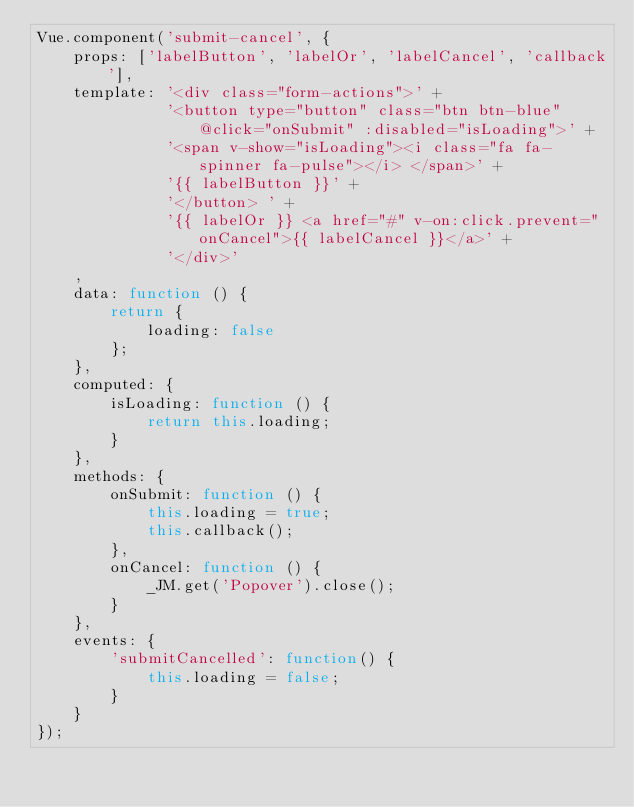<code> <loc_0><loc_0><loc_500><loc_500><_JavaScript_>Vue.component('submit-cancel', {
    props: ['labelButton', 'labelOr', 'labelCancel', 'callback'],
    template: '<div class="form-actions">' +
              '<button type="button" class="btn btn-blue" @click="onSubmit" :disabled="isLoading">' +
              '<span v-show="isLoading"><i class="fa fa-spinner fa-pulse"></i> </span>' +
              '{{ labelButton }}' +
              '</button> ' +
              '{{ labelOr }} <a href="#" v-on:click.prevent="onCancel">{{ labelCancel }}</a>' +
              '</div>'
    ,
    data: function () {
        return {
            loading: false
        };
    },
    computed: {
        isLoading: function () {
            return this.loading;
        }
    },
    methods: {
        onSubmit: function () {
            this.loading = true;
            this.callback();
        },
        onCancel: function () {
            _JM.get('Popover').close();
        }
    },
    events: {
        'submitCancelled': function() {
            this.loading = false;
        }
    }
});</code> 